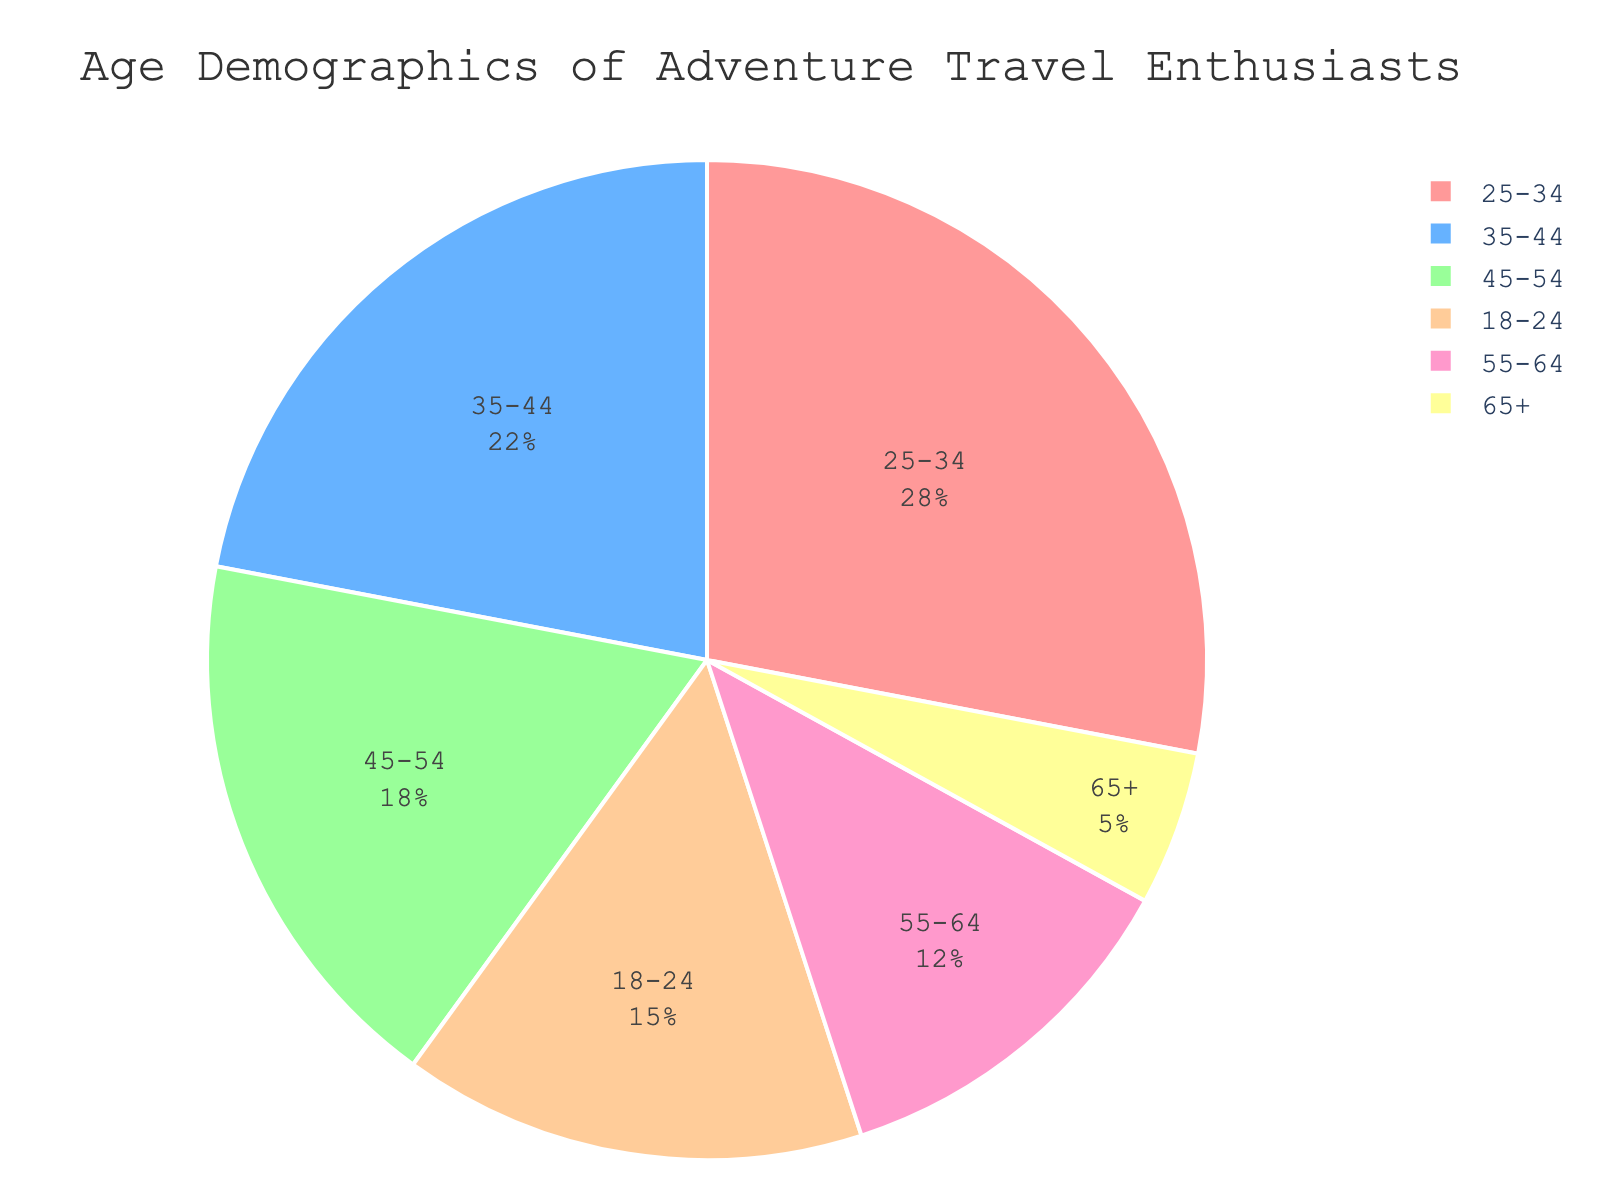What is the age group with the highest percentage of adventure travel enthusiasts? The pie chart shows different age groups and their corresponding percentages. By comparing the values, we see that the age group 25-34 has the highest percentage of 28%.
Answer: 25-34 Which age group has the smallest representation among adventure travel enthusiasts? Looking at the sections of the pie chart, the age group that occupies the smallest segment and has the smallest percentage is 65+, with only 5%.
Answer: 65+ What is the combined percentage of adventure travel enthusiasts aged 18-24 and 35-44? Add the percentage values of the two age groups: 18-24 is 15%, and 35-44 is 22%. Therefore, the combined percentage is 15% + 22% = 37%.
Answer: 37% How does the percentage of the 45-54 age group compare to the 55-64 age group? The pie chart shows that the percentage for the 45-54 age group is 18%, while for the 55-64 age group, it is 12%. Comparing these, 45-54 has a higher percentage than 55-64.
Answer: 45-54 > 55-64 What is the total percentage of adventure travel enthusiasts aged 35-64? Add the percentages of the age groups: 35-44, 45-54, and 55-64. The percentages are 22%, 18%, and 12% respectively. Summing these gives 22% + 18% + 12% = 52%.
Answer: 52% Which color represents the 25-34 age group in the pie chart? The pie chart uses a specific color palette. The 25-34 age group is represented by the second color from the custom palette, which is a shade of blue.
Answer: Blue Is the percentage of adventure travel enthusiasts aged 65+ less than a quarter of those aged 25-34? The percentage of the 65+ age group is 5%, and the percentage of the 25-34 age group is 28%. A quarter of 28% is 7%. Since 5% is less than 7%, the statement is true.
Answer: Yes What is the difference in percentage between the age groups 35-44 and 18-24? The percentage for 35-44 is 22% and for 18-24 is 15%. The difference is obtained by subtracting the smaller percentage from the larger one: 22% - 15% = 7%.
Answer: 7% What portion of the pie chart is represented by age groups younger than 35? Add the percentages of age groups 18-24 and 25-34. These percentages are 15% and 28% respectively: 15% + 28% = 43%.
Answer: 43% What percentage of adventure travel enthusiasts are aged 45 or older? Sum the percentages of the age groups 45-54, 55-64, and 65+. These values are 18%, 12%, and 5%. Adding them gives: 18% + 12% + 5% = 35%.
Answer: 35% 